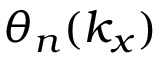<formula> <loc_0><loc_0><loc_500><loc_500>\theta _ { n } ( k _ { x } )</formula> 